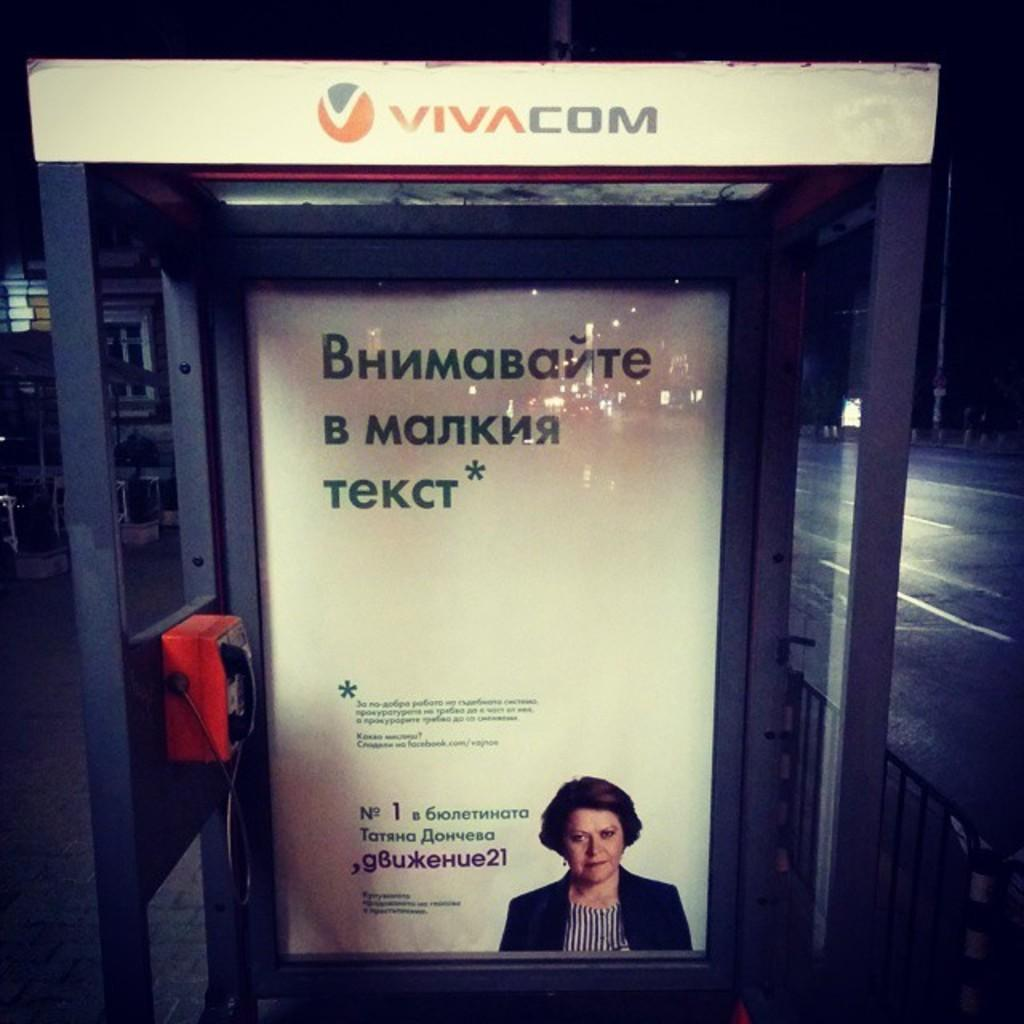What structure is present in the image? There is a telephone booth in the image. What can be seen on the left side of the telephone booth? There is a red telephone on the left side of the booth. What is located at the back of the telephone booth? There is a poster at the back of the booth. What type of barrier is visible in the image? There is fencing in the image. What type of pathway is present in the image? There is a road in the image. What vertical structure can be seen in the image? There is a pole in the image. What type of frame is visible around the telephone booth in the image? There is no frame visible around the telephone booth in the image. Is there any water visible in the image? No, there is no water present in the image. 